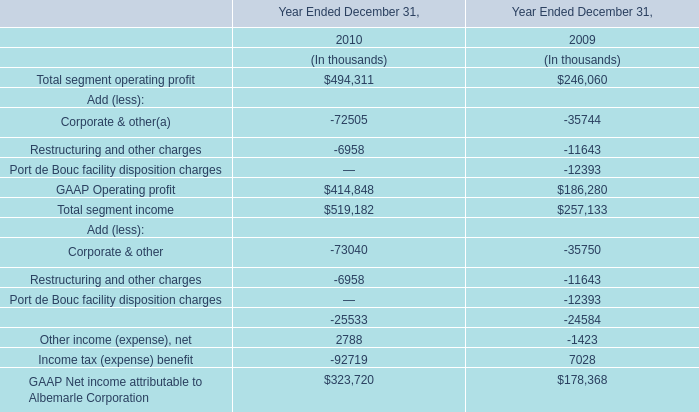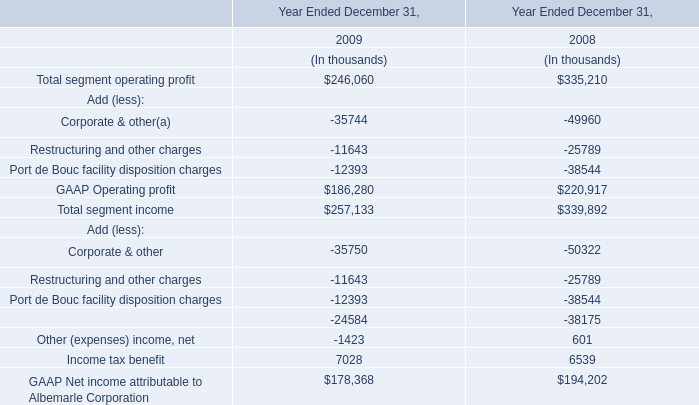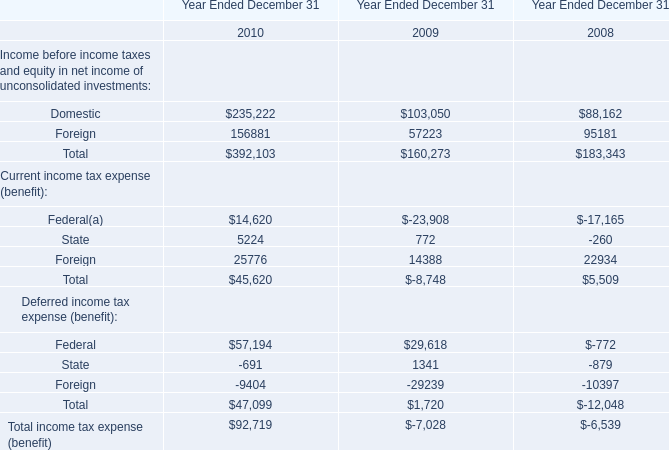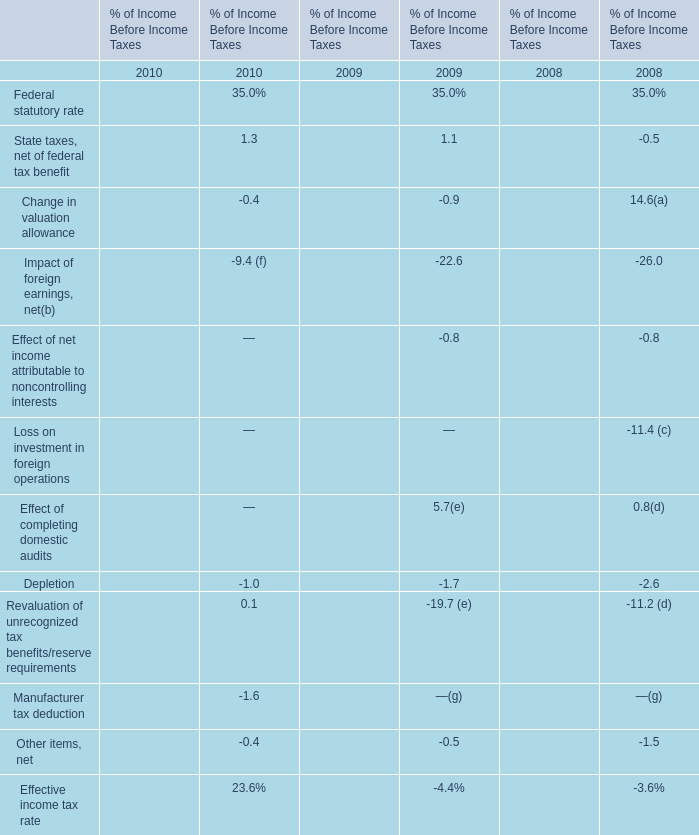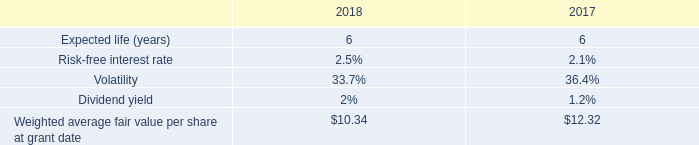what is the growth rate in weighted average fair value per share from 2017 to 2018? 
Computations: ((10.34 - 12.32) / 12.32)
Answer: -0.16071. 